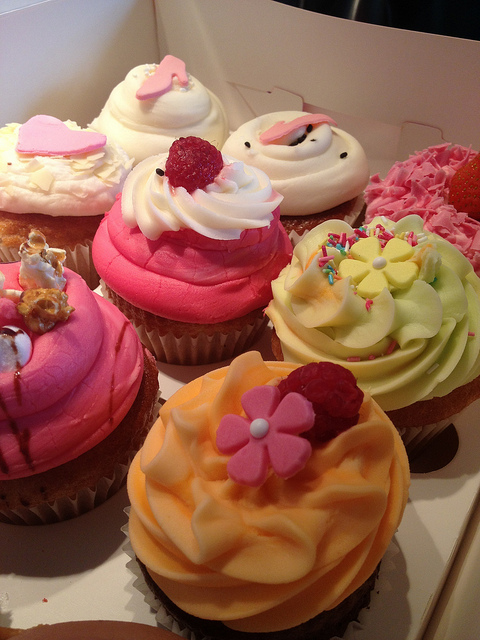Can you describe the occasion these cupcakes might be suitable for? These cupcakes, with their vibrant colors and playful decorations, would be perfect for a variety of joyful occasions. They could grace the table at a birthday party, serve as the sweet note in a bridal shower, or add a touch of whimsy to a friendly gathering. Their charming appearance makes them versatile for both casual and celebratory events. 